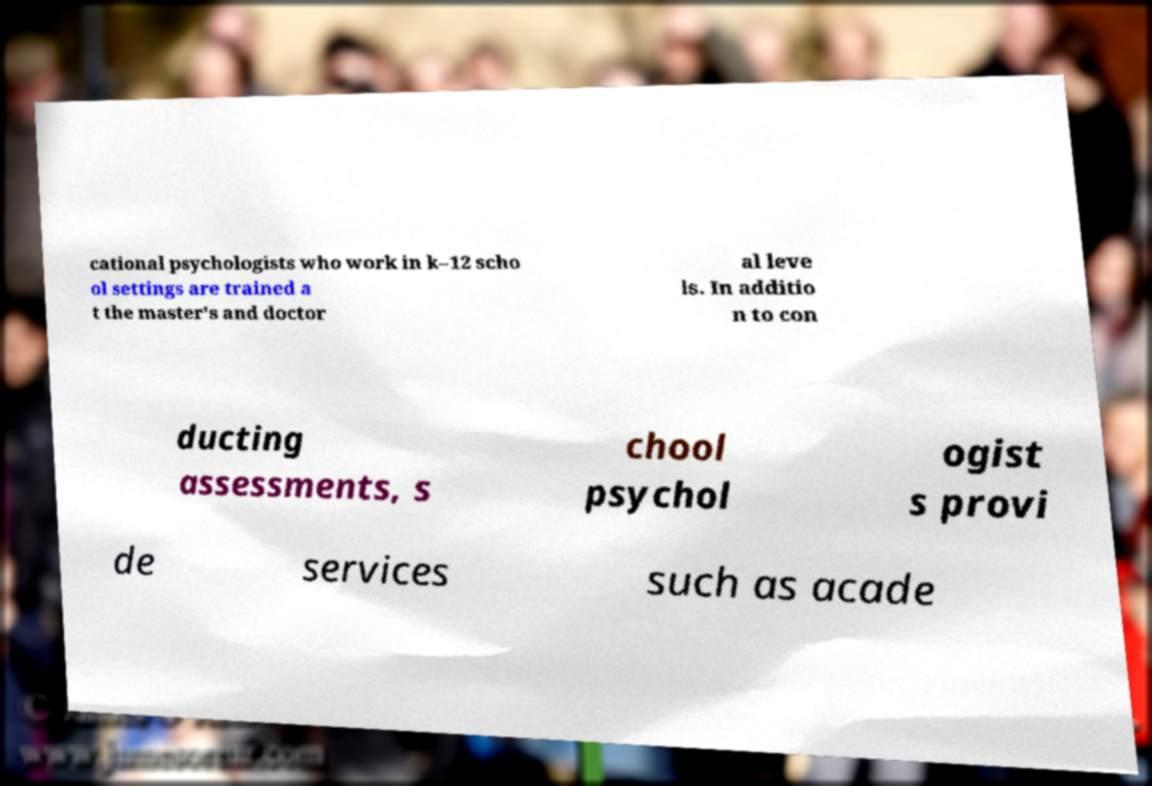For documentation purposes, I need the text within this image transcribed. Could you provide that? cational psychologists who work in k–12 scho ol settings are trained a t the master's and doctor al leve ls. In additio n to con ducting assessments, s chool psychol ogist s provi de services such as acade 